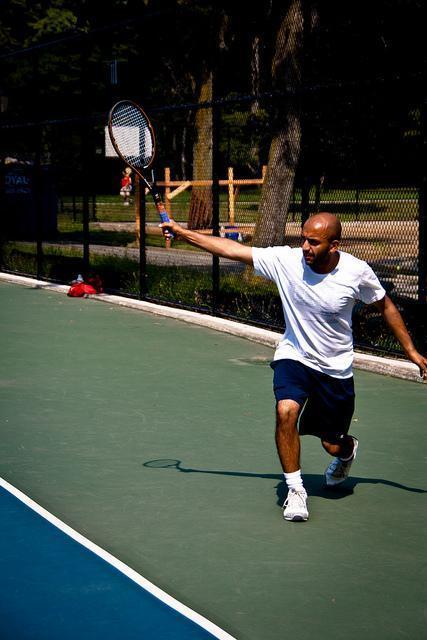How many sweatbands is the man wearing?
Give a very brief answer. 0. How many children are on bicycles in this image?
Give a very brief answer. 0. 